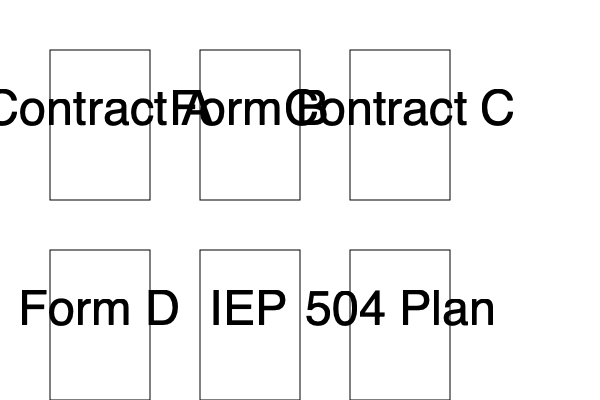Which legal document in the image is specifically designed to ensure equal access to education for students with disabilities under Section 504 of the Rehabilitation Act? 1. Analyze the six documents presented in the image:
   - Contract A, Form B, Contract C
   - Form D, IEP, 504 Plan

2. Identify education-related documents:
   - IEP (Individualized Education Program)
   - 504 Plan

3. Understand the purpose of each:
   - IEP: For students who qualify for special education services under IDEA
   - 504 Plan: For students with disabilities who need accommodations but don't require special education

4. Recognize that Section 504 of the Rehabilitation Act prohibits discrimination against individuals with disabilities in programs receiving federal funding, including schools.

5. Match the question's requirement to "ensure equal access to education for students with disabilities under Section 504" with the 504 Plan, which is specifically designed for this purpose.
Answer: 504 Plan 